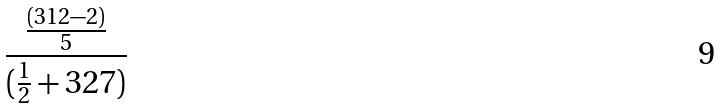Convert formula to latex. <formula><loc_0><loc_0><loc_500><loc_500>\frac { \frac { ( 3 1 2 - 2 ) } { 5 } } { ( \frac { 1 } { 2 } + 3 2 7 ) }</formula> 